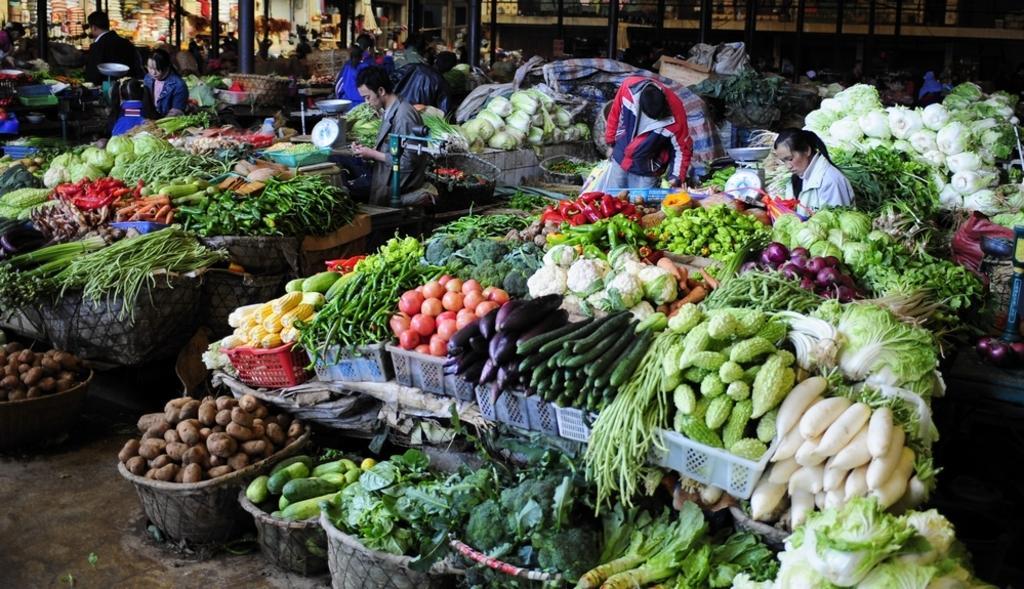Could you give a brief overview of what you see in this image? In this picture I can observe a vegetable market. There are number of different vegetables. There are some people in this picture. In the background I can observe black color poles. 